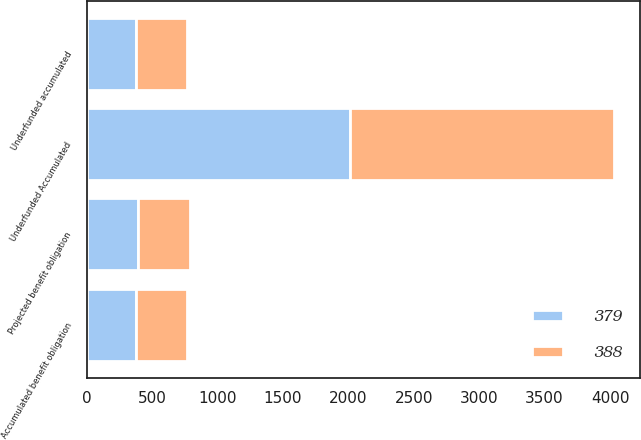Convert chart. <chart><loc_0><loc_0><loc_500><loc_500><stacked_bar_chart><ecel><fcel>Underfunded Accumulated<fcel>Projected benefit obligation<fcel>Accumulated benefit obligation<fcel>Underfunded accumulated<nl><fcel>388<fcel>2015<fcel>398<fcel>388<fcel>388<nl><fcel>379<fcel>2014<fcel>388<fcel>379<fcel>379<nl></chart> 